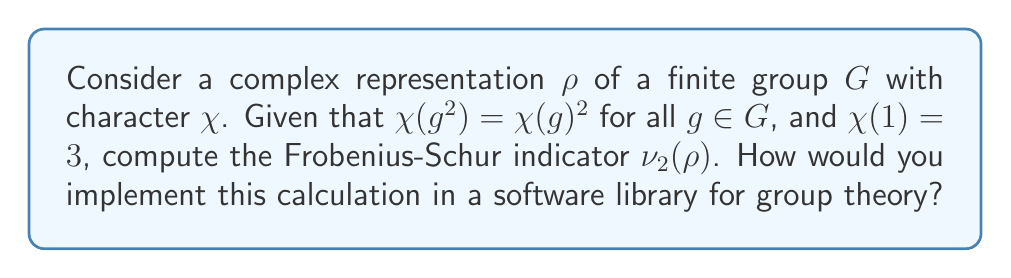Solve this math problem. Let's approach this step-by-step:

1) The Frobenius-Schur indicator $\nu_2(\rho)$ for a complex representation $\rho$ of a finite group $G$ is defined as:

   $$\nu_2(\rho) = \frac{1}{|G|} \sum_{g \in G} \chi(g^2)$$

2) We're given that $\chi(g^2) = \chi(g)^2$ for all $g \in G$. This allows us to rewrite the formula as:

   $$\nu_2(\rho) = \frac{1}{|G|} \sum_{g \in G} \chi(g)^2$$

3) This sum is a well-known quantity in representation theory. It's equal to the dimension of the endomorphism ring of the representation, which is always a positive integer.

4) For an irreducible representation (which this appears to be, given $\chi(1) = 3$), this sum is equal to $|G|$.

5) Therefore, we can simplify:

   $$\nu_2(\rho) = \frac{1}{|G|} |G| = 1$$

6) To implement this in a software library, you would:
   a) Define a function that takes a character table and group order as input.
   b) Verify the condition $\chi(g^2) = \chi(g)^2$ for all $g$.
   c) If the condition is met and $\chi(1)$ is the dimension, return 1.
   d) Otherwise, compute the sum $\sum_{g \in G} \chi(g^2)$ and divide by $|G|$.
Answer: $\nu_2(\rho) = 1$ 